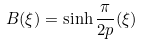Convert formula to latex. <formula><loc_0><loc_0><loc_500><loc_500>B ( \xi ) = \sinh \frac { \pi } { 2 p } ( \xi )</formula> 